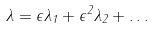<formula> <loc_0><loc_0><loc_500><loc_500>\lambda = \epsilon \lambda _ { 1 } + \epsilon ^ { 2 } \lambda _ { 2 } + \dots</formula> 